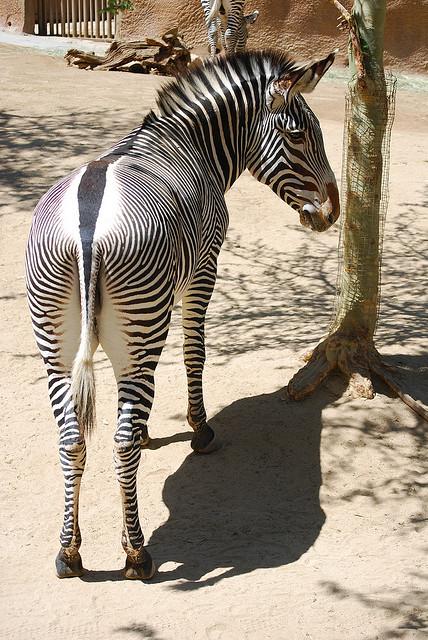What animal is this?
Concise answer only. Zebra. What part of the animal is facing the photo?
Write a very short answer. Butt. What is cast?
Keep it brief. Shadow. 